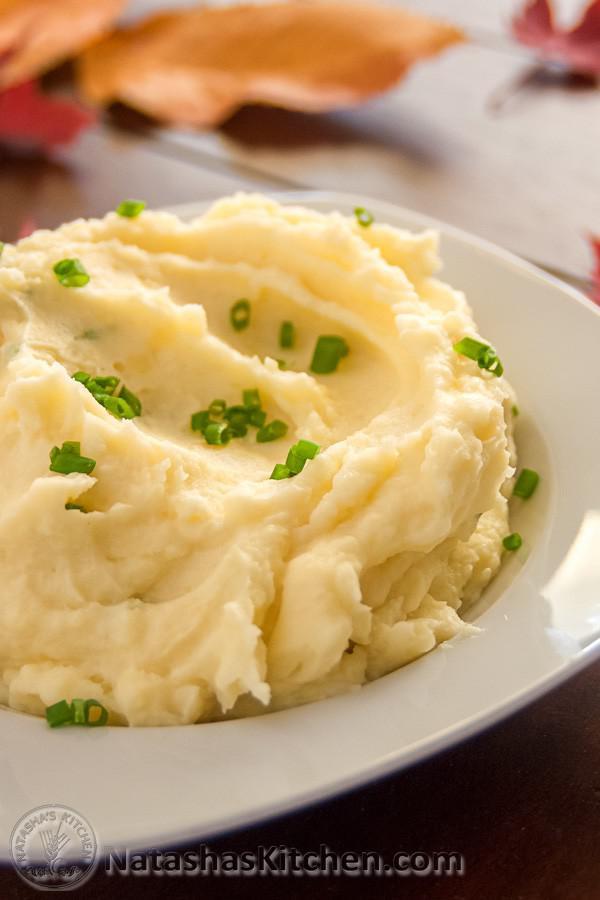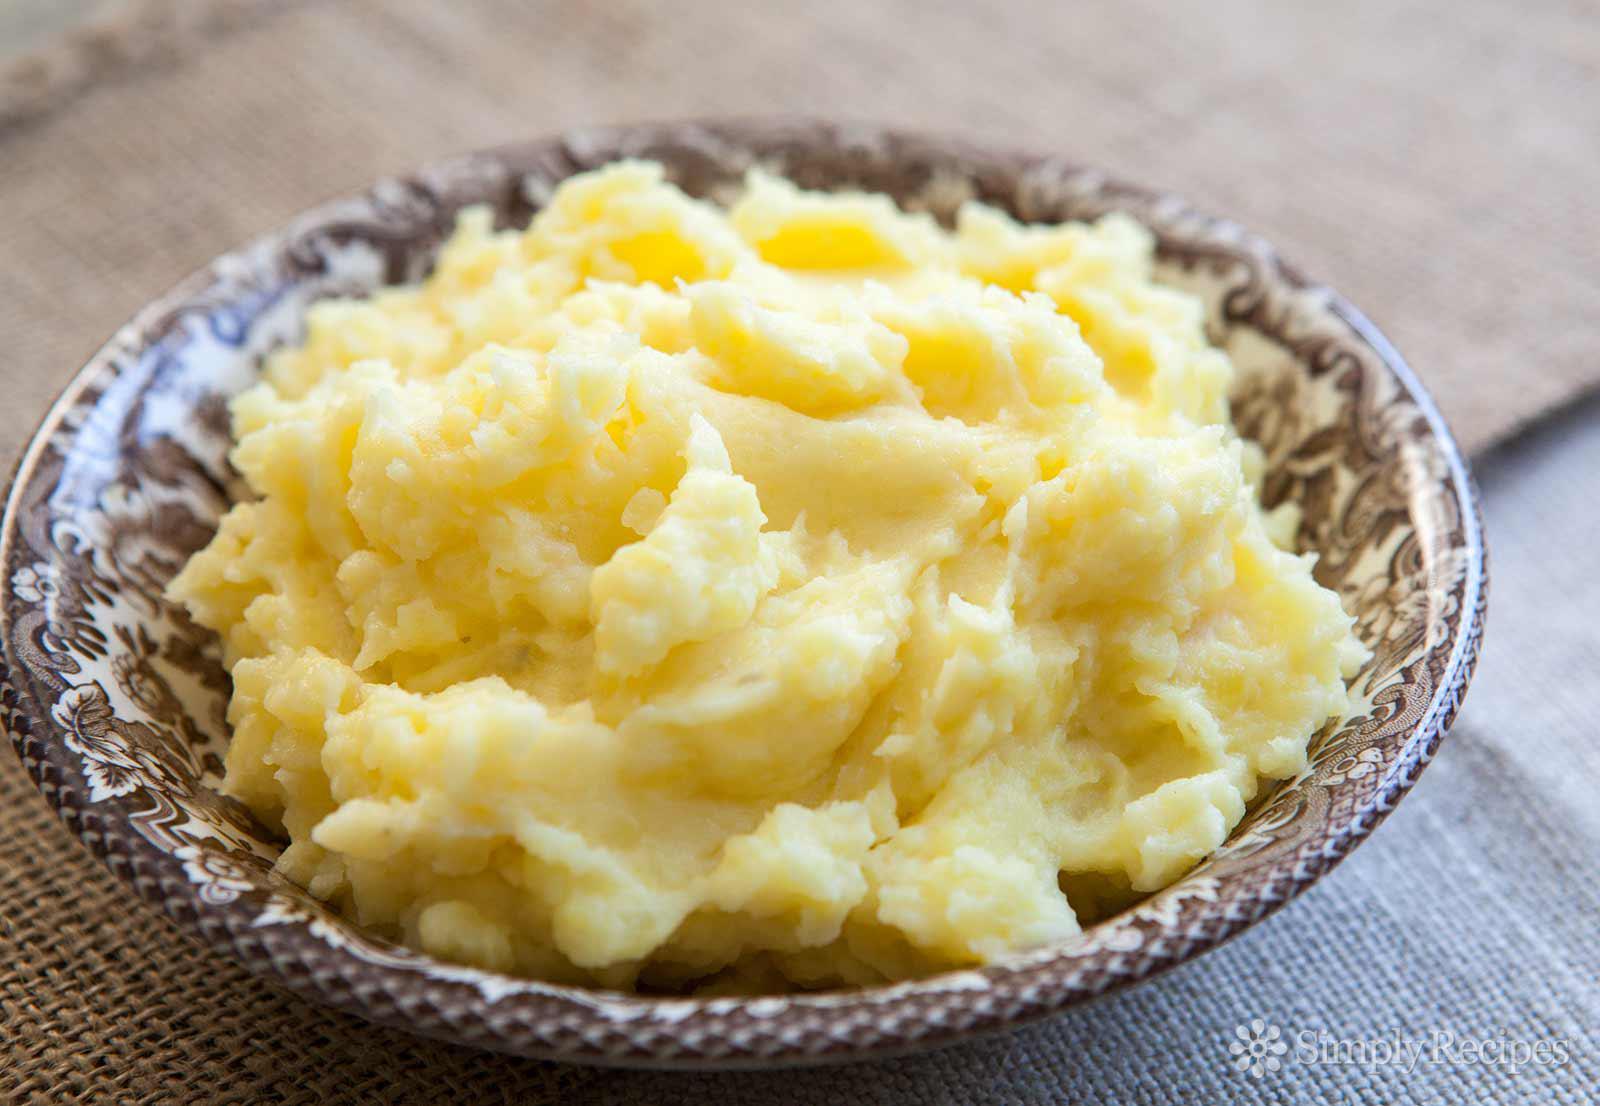The first image is the image on the left, the second image is the image on the right. For the images shown, is this caption "there is a utensil in one of the images" true? Answer yes or no. No. The first image is the image on the left, the second image is the image on the right. Examine the images to the left and right. Is the description "One bowl of potatoes has only green chive garnish." accurate? Answer yes or no. Yes. 